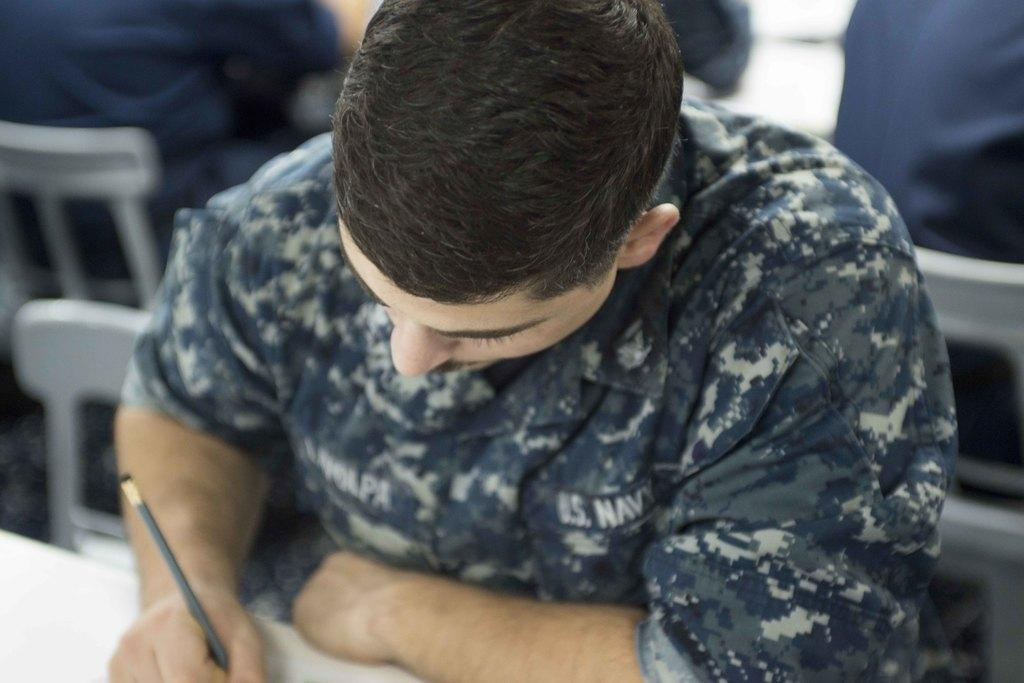What is the person in the image holding? The person is holding a pencil in the image. What is the person doing with the pencil? The person is writing with the pencil. Can you describe the setting in the background of the image? There are people sitting on chairs in the background of the image. What type of yak can be seen wearing a shirt in the image? There is no yak or shirt present in the image. What is the air quality like in the image? The provided facts do not give any information about the air quality in the image. 